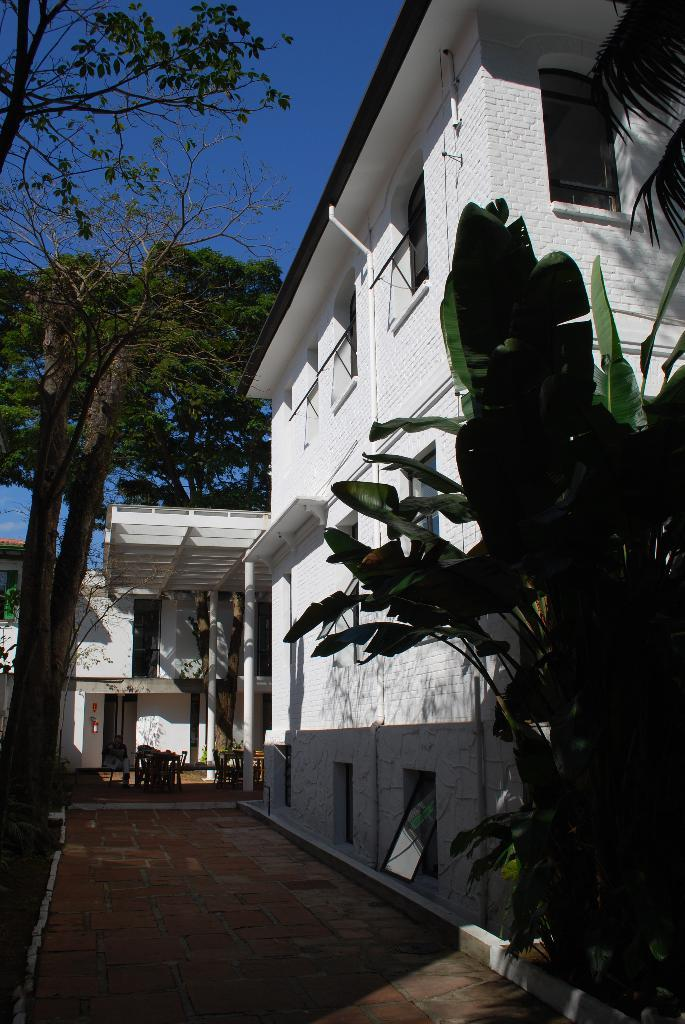What type of structures are visible in the image? There are houses in the image. What type of vegetation is present in the image? There are trees in the image. What type of furniture is visible in the image? There are chairs in the image. What is the person in the image doing? There is a person sitting in the image. What is at the bottom of the image? There is a pathway at the bottom of the image. What can be seen in the background of the image? The sky is visible in the background of the image. What caption is written on the person's shirt in the image? There is no caption visible on the person's shirt in the image. What type of activity is the person engaging in with the chairs in the image? The person is sitting in the image, but there is no indication of any activity involving the chairs. 